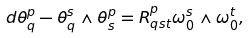Convert formula to latex. <formula><loc_0><loc_0><loc_500><loc_500>d \theta _ { q } ^ { p } - \theta _ { q } ^ { s } \wedge \theta _ { s } ^ { p } = R ^ { p } _ { q s t } \omega _ { 0 } ^ { s } \wedge \omega _ { 0 } ^ { t } ,</formula> 